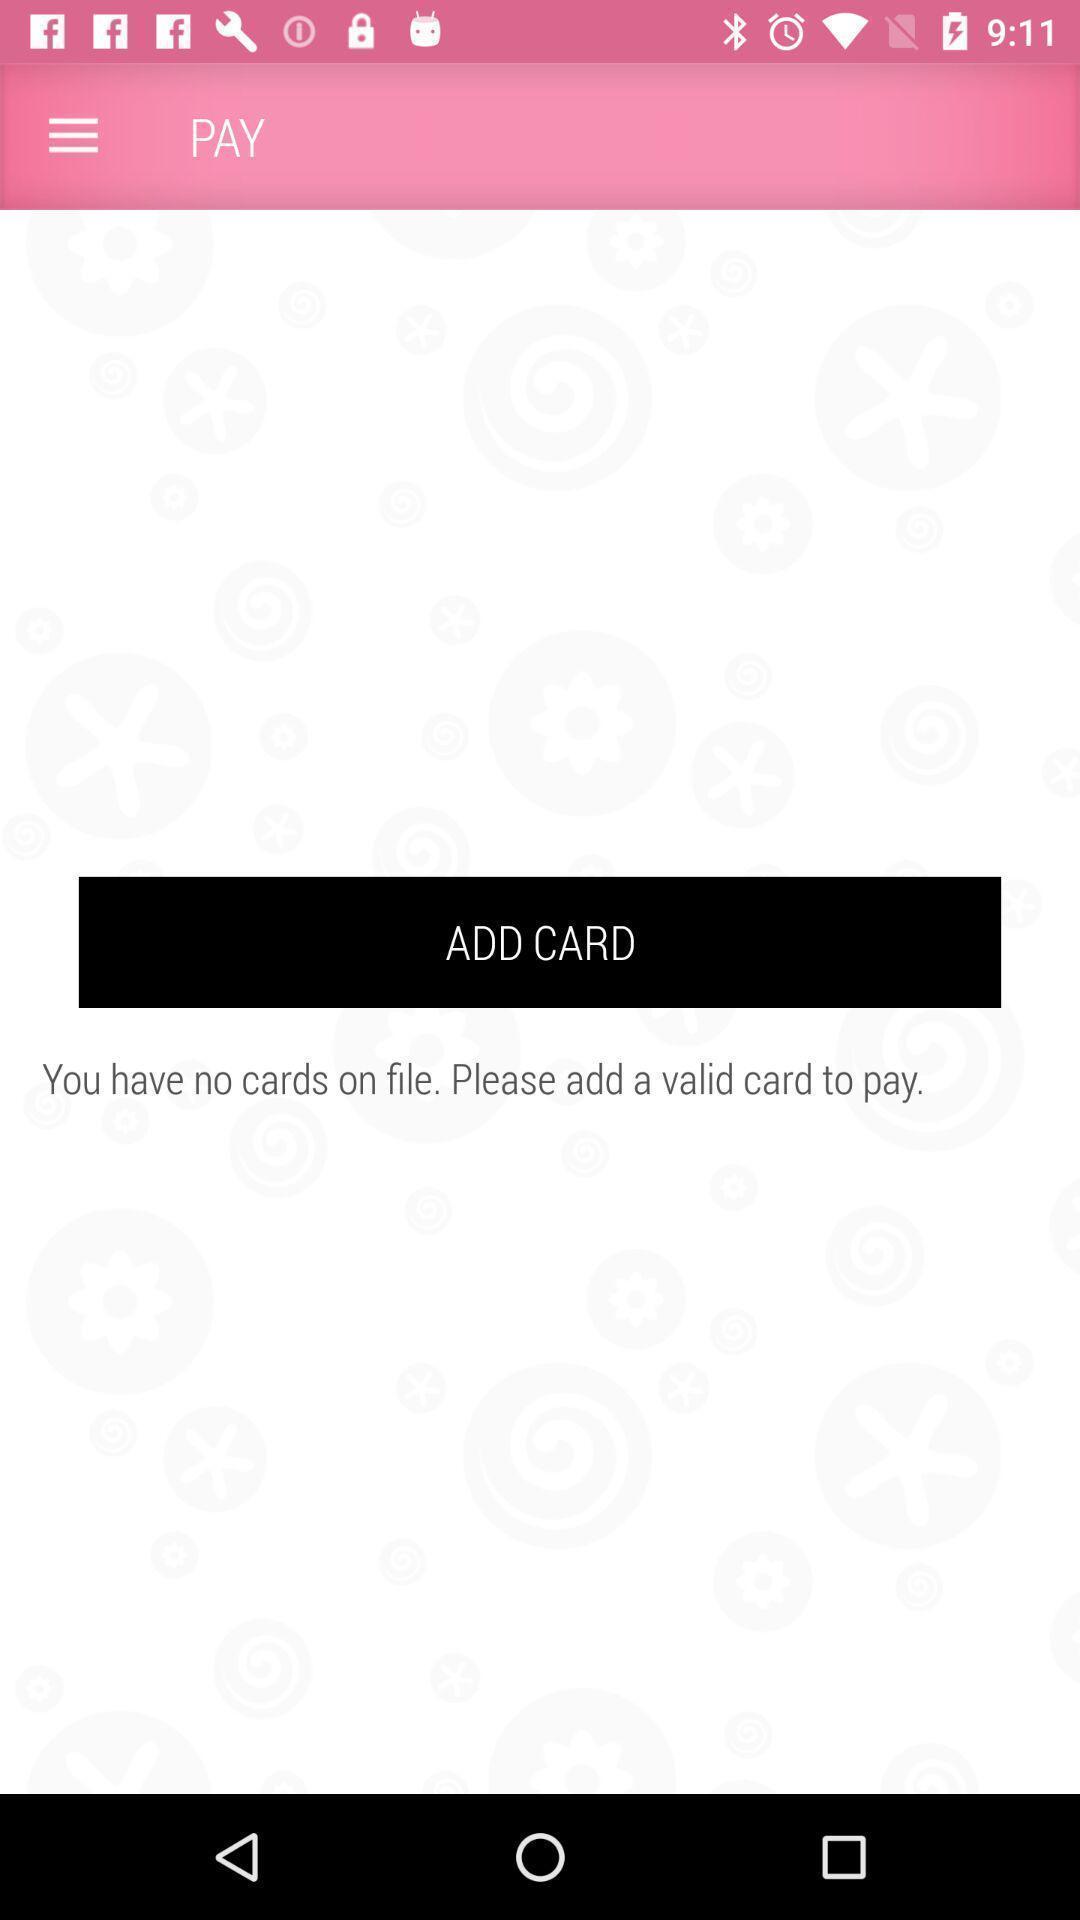Summarize the main components in this picture. Page showing to add card in app. 